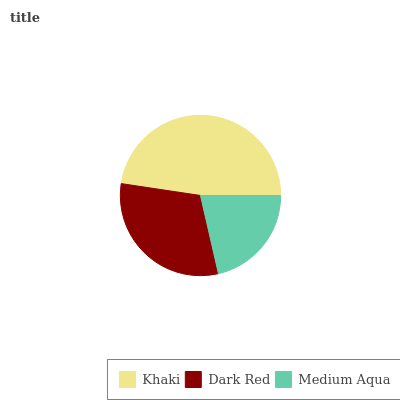Is Medium Aqua the minimum?
Answer yes or no. Yes. Is Khaki the maximum?
Answer yes or no. Yes. Is Dark Red the minimum?
Answer yes or no. No. Is Dark Red the maximum?
Answer yes or no. No. Is Khaki greater than Dark Red?
Answer yes or no. Yes. Is Dark Red less than Khaki?
Answer yes or no. Yes. Is Dark Red greater than Khaki?
Answer yes or no. No. Is Khaki less than Dark Red?
Answer yes or no. No. Is Dark Red the high median?
Answer yes or no. Yes. Is Dark Red the low median?
Answer yes or no. Yes. Is Khaki the high median?
Answer yes or no. No. Is Khaki the low median?
Answer yes or no. No. 